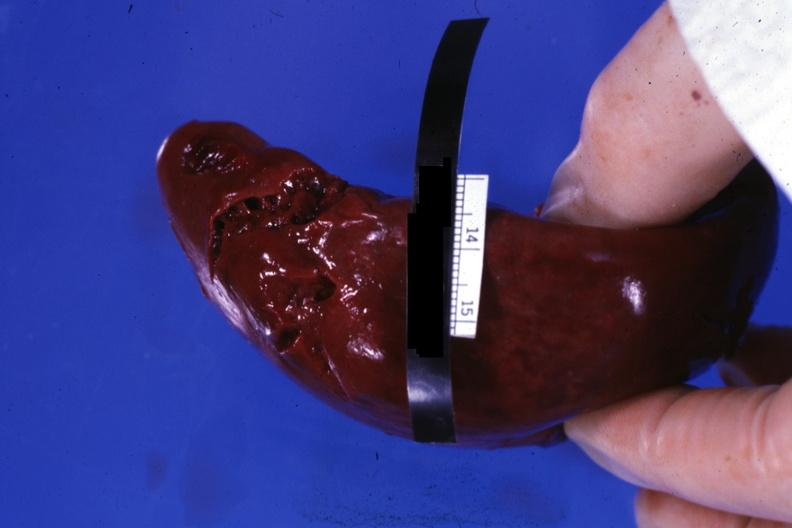what done done during surgical procedure?
Answer the question using a single word or phrase. External view of lacerations of capsule 